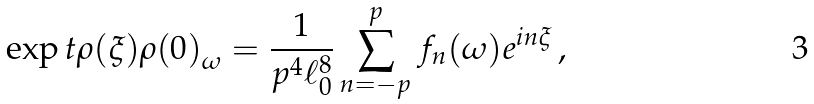Convert formula to latex. <formula><loc_0><loc_0><loc_500><loc_500>\exp t { \rho ( \xi ) \rho ( 0 ) } _ { \omega } = \frac { 1 } { p ^ { 4 } \ell _ { 0 } ^ { 8 } } \sum _ { n = - p } ^ { p } f _ { n } ( \omega ) e ^ { i n \xi } \, ,</formula> 